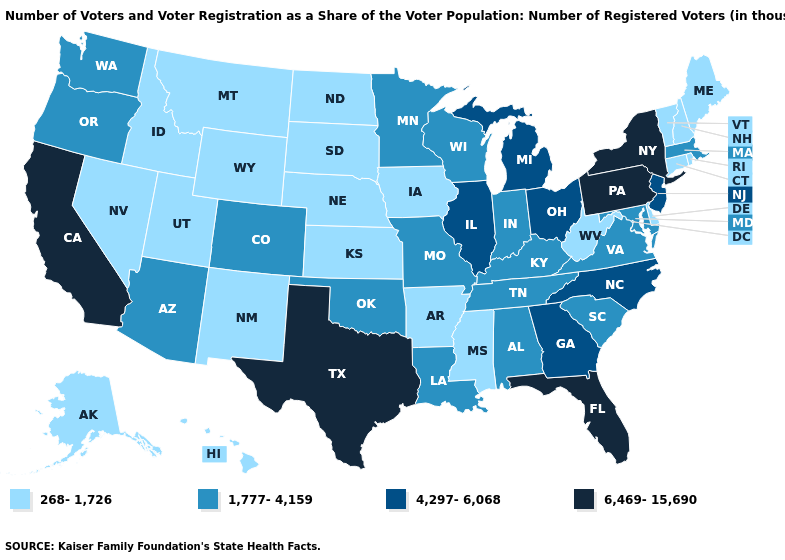What is the lowest value in states that border Connecticut?
Answer briefly. 268-1,726. Name the states that have a value in the range 1,777-4,159?
Quick response, please. Alabama, Arizona, Colorado, Indiana, Kentucky, Louisiana, Maryland, Massachusetts, Minnesota, Missouri, Oklahoma, Oregon, South Carolina, Tennessee, Virginia, Washington, Wisconsin. Among the states that border California , which have the highest value?
Give a very brief answer. Arizona, Oregon. Does Mississippi have the lowest value in the South?
Answer briefly. Yes. What is the value of West Virginia?
Be succinct. 268-1,726. What is the value of Maryland?
Concise answer only. 1,777-4,159. Does the first symbol in the legend represent the smallest category?
Give a very brief answer. Yes. Does New York have the lowest value in the Northeast?
Write a very short answer. No. Name the states that have a value in the range 6,469-15,690?
Keep it brief. California, Florida, New York, Pennsylvania, Texas. What is the value of Mississippi?
Be succinct. 268-1,726. Among the states that border Massachusetts , does New York have the lowest value?
Answer briefly. No. Which states have the lowest value in the USA?
Answer briefly. Alaska, Arkansas, Connecticut, Delaware, Hawaii, Idaho, Iowa, Kansas, Maine, Mississippi, Montana, Nebraska, Nevada, New Hampshire, New Mexico, North Dakota, Rhode Island, South Dakota, Utah, Vermont, West Virginia, Wyoming. What is the value of West Virginia?
Give a very brief answer. 268-1,726. Does South Carolina have a lower value than Washington?
Write a very short answer. No. Name the states that have a value in the range 6,469-15,690?
Write a very short answer. California, Florida, New York, Pennsylvania, Texas. 